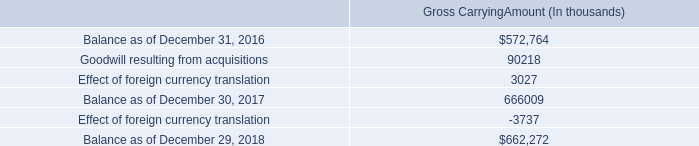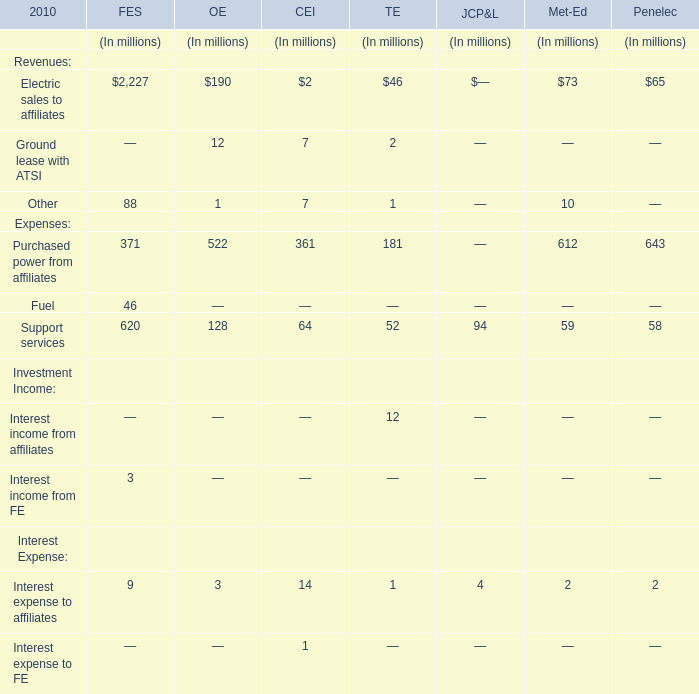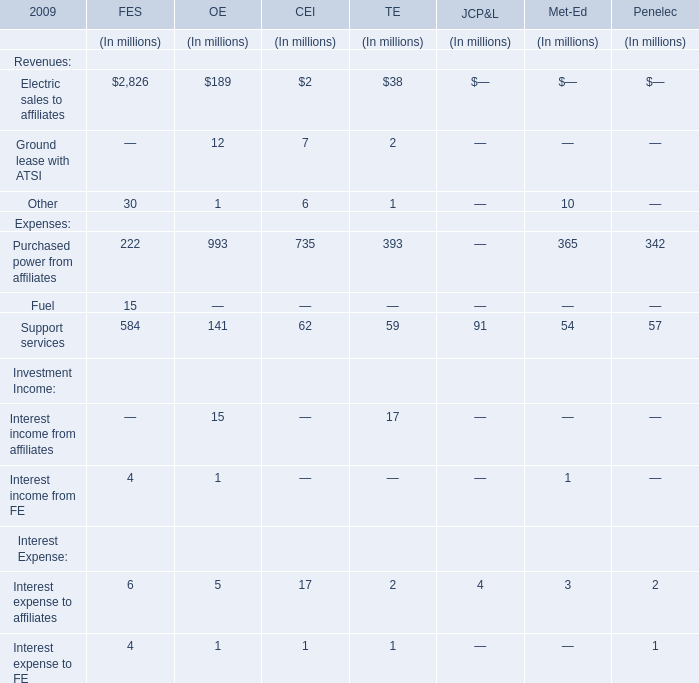What is the sum of Revenues in terms of OE in the range of 100 and 200 in 2010? (in million) 
Answer: 190. 